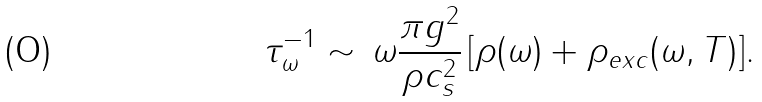Convert formula to latex. <formula><loc_0><loc_0><loc_500><loc_500>\tau _ { \omega } ^ { - 1 } \sim \, \omega \frac { \pi g ^ { 2 } } { \rho c _ { s } ^ { 2 } } \, [ \rho ( \omega ) + \rho _ { e x c } ( \omega , T ) ] .</formula> 